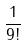Convert formula to latex. <formula><loc_0><loc_0><loc_500><loc_500>\frac { 1 } { 9 ! }</formula> 